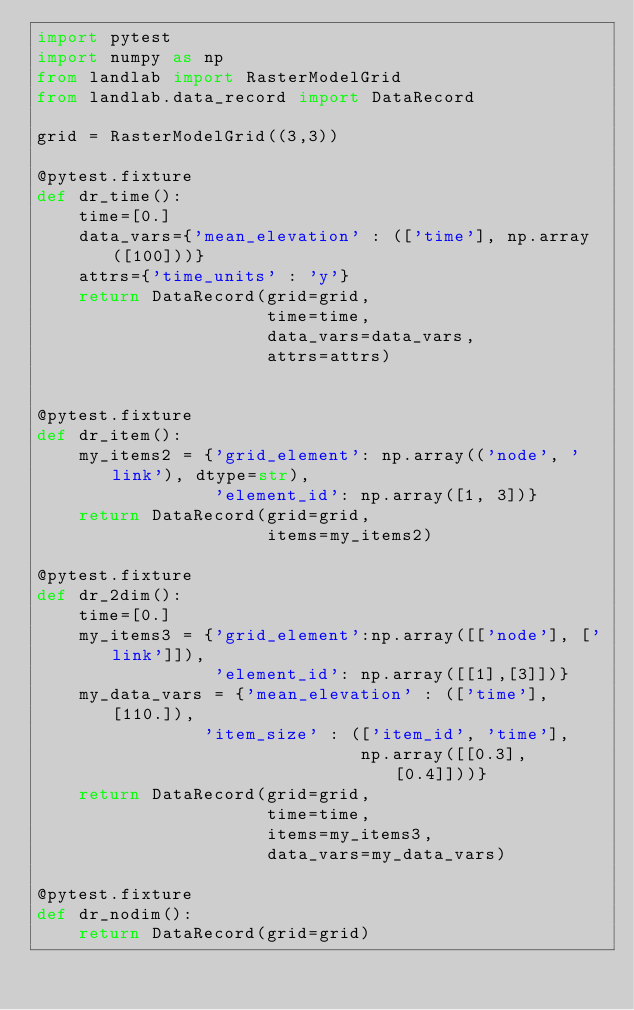Convert code to text. <code><loc_0><loc_0><loc_500><loc_500><_Python_>import pytest
import numpy as np
from landlab import RasterModelGrid
from landlab.data_record import DataRecord

grid = RasterModelGrid((3,3))

@pytest.fixture
def dr_time():
    time=[0.]
    data_vars={'mean_elevation' : (['time'], np.array([100]))}
    attrs={'time_units' : 'y'}
    return DataRecord(grid=grid,
                      time=time,
                      data_vars=data_vars,
                      attrs=attrs)


@pytest.fixture
def dr_item():
    my_items2 = {'grid_element': np.array(('node', 'link'), dtype=str),
                 'element_id': np.array([1, 3])}
    return DataRecord(grid=grid,
                      items=my_items2)

@pytest.fixture
def dr_2dim():
    time=[0.]
    my_items3 = {'grid_element':np.array([['node'], ['link']]),
                 'element_id': np.array([[1],[3]])}
    my_data_vars = {'mean_elevation' : (['time'], [110.]),
                'item_size' : (['item_id', 'time'],
                               np.array([[0.3], [0.4]]))}
    return DataRecord(grid=grid,
                      time=time,
                      items=my_items3,
                      data_vars=my_data_vars)

@pytest.fixture
def dr_nodim():
    return DataRecord(grid=grid)

</code> 